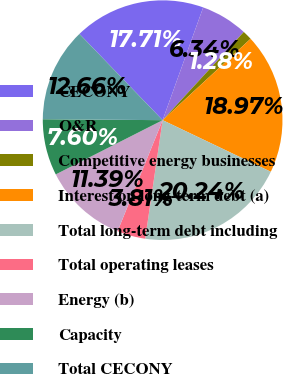Convert chart to OTSL. <chart><loc_0><loc_0><loc_500><loc_500><pie_chart><fcel>CECONY<fcel>O&R<fcel>Competitive energy businesses<fcel>Interest on long-term debt (a)<fcel>Total long-term debt including<fcel>Total operating leases<fcel>Energy (b)<fcel>Capacity<fcel>Total CECONY<nl><fcel>17.71%<fcel>6.34%<fcel>1.28%<fcel>18.97%<fcel>20.24%<fcel>3.81%<fcel>11.39%<fcel>7.6%<fcel>12.66%<nl></chart> 